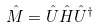Convert formula to latex. <formula><loc_0><loc_0><loc_500><loc_500>\hat { M } = \hat { U } \hat { H } \hat { U } ^ { \dagger }</formula> 